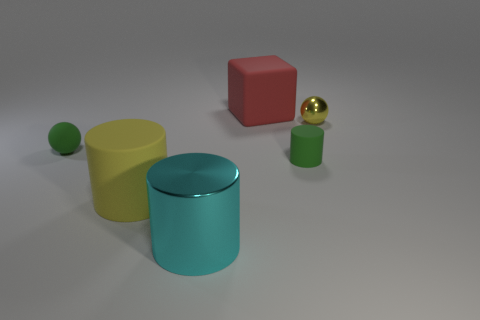Add 4 tiny metal objects. How many objects exist? 10 Subtract all blocks. How many objects are left? 5 Add 6 tiny red spheres. How many tiny red spheres exist? 6 Subtract 0 purple balls. How many objects are left? 6 Subtract all cyan shiny cylinders. Subtract all small spheres. How many objects are left? 3 Add 3 large matte cubes. How many large matte cubes are left? 4 